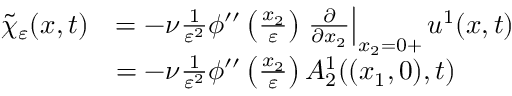Convert formula to latex. <formula><loc_0><loc_0><loc_500><loc_500>\begin{array} { r l } { \tilde { \chi } _ { \varepsilon } ( x , t ) } & { = - \nu \frac { 1 } { \varepsilon ^ { 2 } } \phi ^ { \prime \prime } \left ( \frac { x _ { 2 } } { \varepsilon } \right ) \frac { \partial } { \partial x _ { 2 } } \right | _ { x _ { 2 } = 0 + } u ^ { 1 } ( x , t ) } \\ & { = - \nu \frac { 1 } { \varepsilon ^ { 2 } } \phi ^ { \prime \prime } \left ( \frac { x _ { 2 } } { \varepsilon } \right ) A _ { 2 } ^ { 1 } ( ( x _ { 1 } , 0 ) , t ) } \end{array}</formula> 